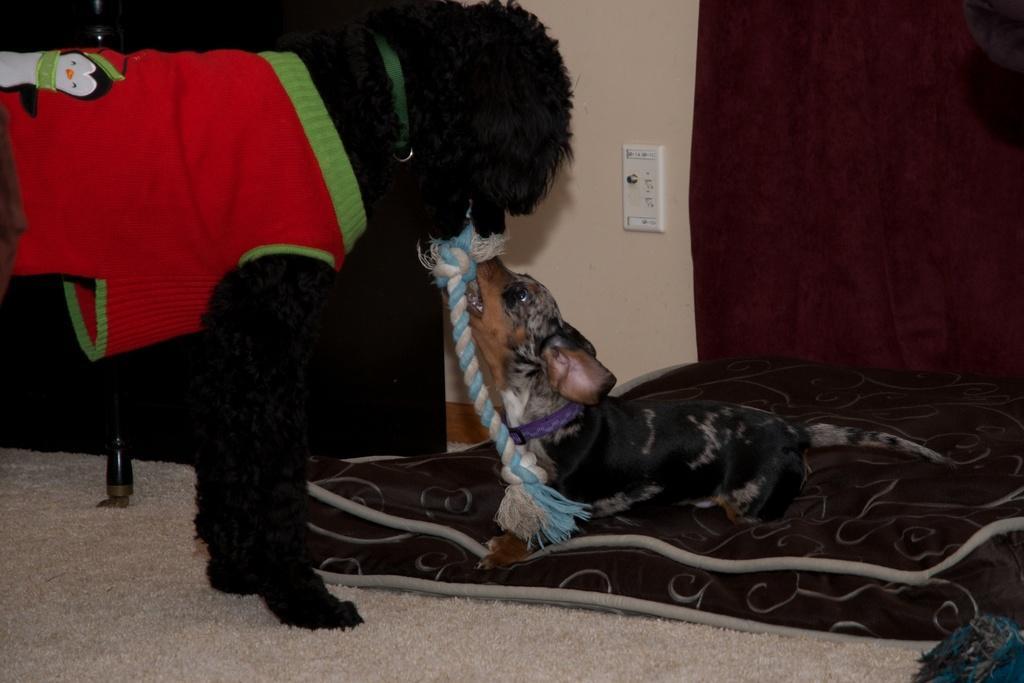In one or two sentences, can you explain what this image depicts? This image consists of a dog in black color. It is tied with a belt. At the bottom, there is another dog sitting on the bed. At the bottom, there is a floor mat. In the background, there is a wall. 